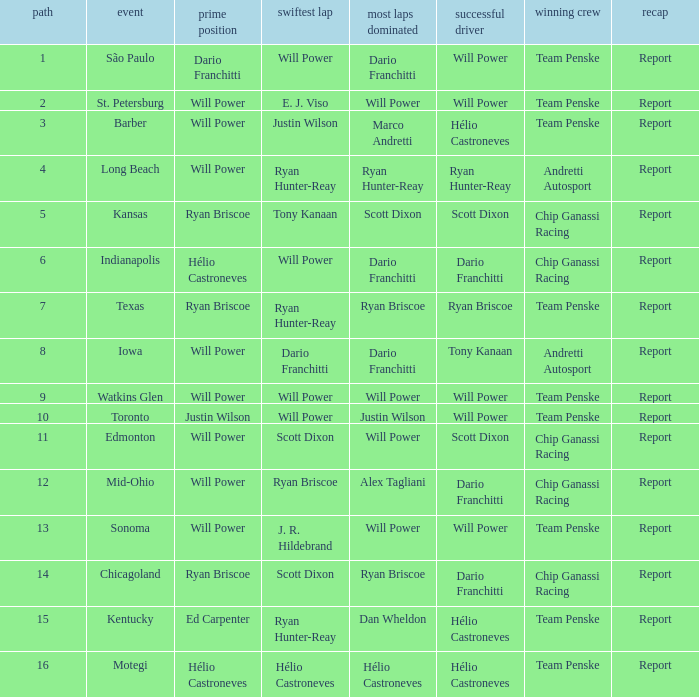In what position did the winning driver finish at Chicagoland? 1.0. 